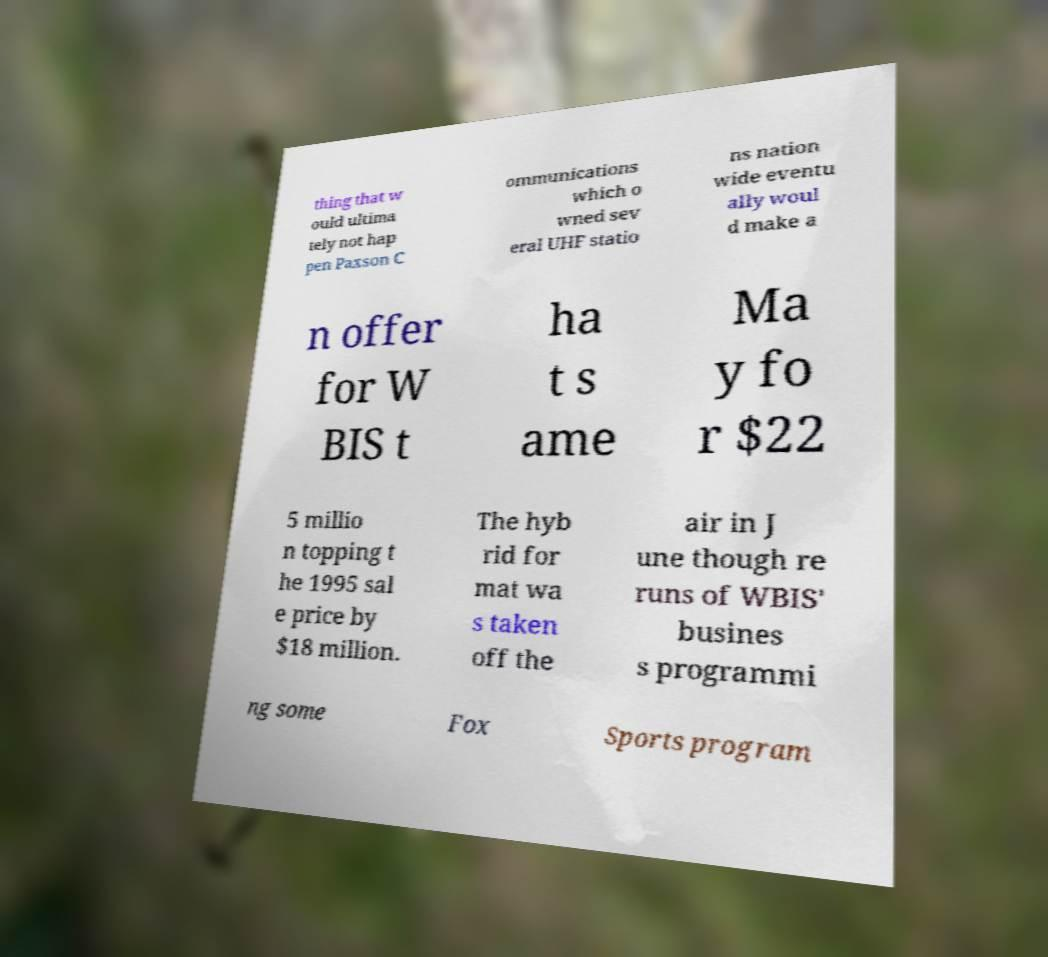Could you extract and type out the text from this image? thing that w ould ultima tely not hap pen Paxson C ommunications which o wned sev eral UHF statio ns nation wide eventu ally woul d make a n offer for W BIS t ha t s ame Ma y fo r $22 5 millio n topping t he 1995 sal e price by $18 million. The hyb rid for mat wa s taken off the air in J une though re runs of WBIS' busines s programmi ng some Fox Sports program 